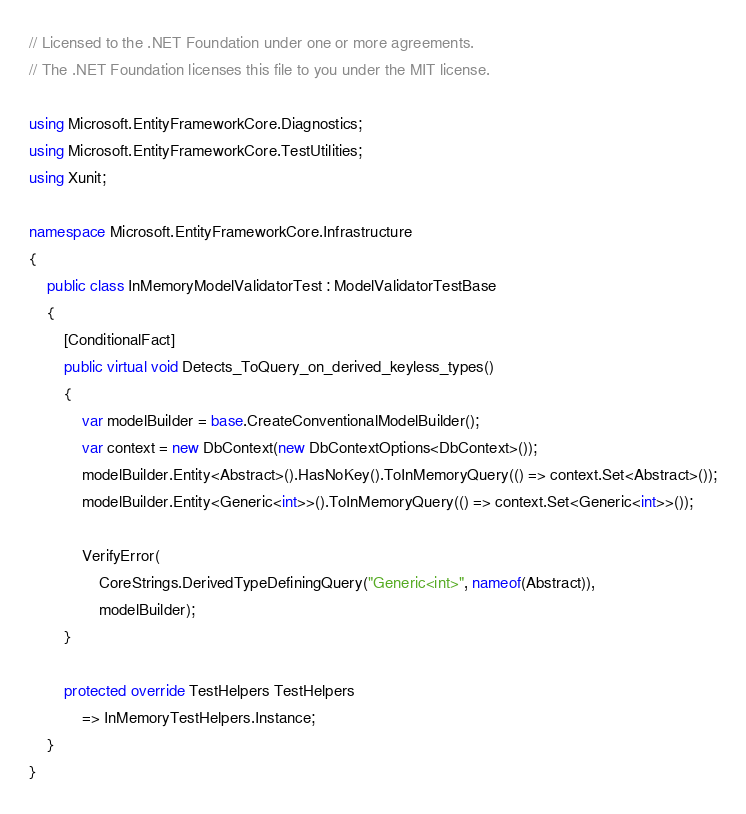<code> <loc_0><loc_0><loc_500><loc_500><_C#_>// Licensed to the .NET Foundation under one or more agreements.
// The .NET Foundation licenses this file to you under the MIT license.

using Microsoft.EntityFrameworkCore.Diagnostics;
using Microsoft.EntityFrameworkCore.TestUtilities;
using Xunit;

namespace Microsoft.EntityFrameworkCore.Infrastructure
{
    public class InMemoryModelValidatorTest : ModelValidatorTestBase
    {
        [ConditionalFact]
        public virtual void Detects_ToQuery_on_derived_keyless_types()
        {
            var modelBuilder = base.CreateConventionalModelBuilder();
            var context = new DbContext(new DbContextOptions<DbContext>());
            modelBuilder.Entity<Abstract>().HasNoKey().ToInMemoryQuery(() => context.Set<Abstract>());
            modelBuilder.Entity<Generic<int>>().ToInMemoryQuery(() => context.Set<Generic<int>>());

            VerifyError(
                CoreStrings.DerivedTypeDefiningQuery("Generic<int>", nameof(Abstract)),
                modelBuilder);
        }

        protected override TestHelpers TestHelpers
            => InMemoryTestHelpers.Instance;
    }
}
</code> 